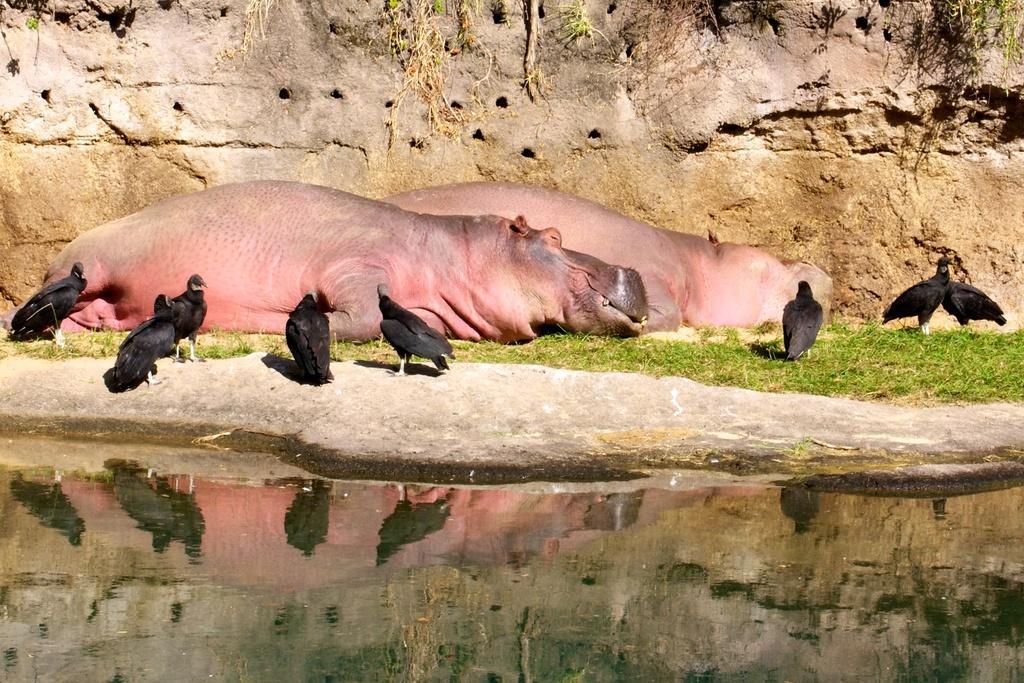In one or two sentences, can you explain what this image depicts? In the image in the center, we can see animals, birds, water and grass. In the background there is a wall. 